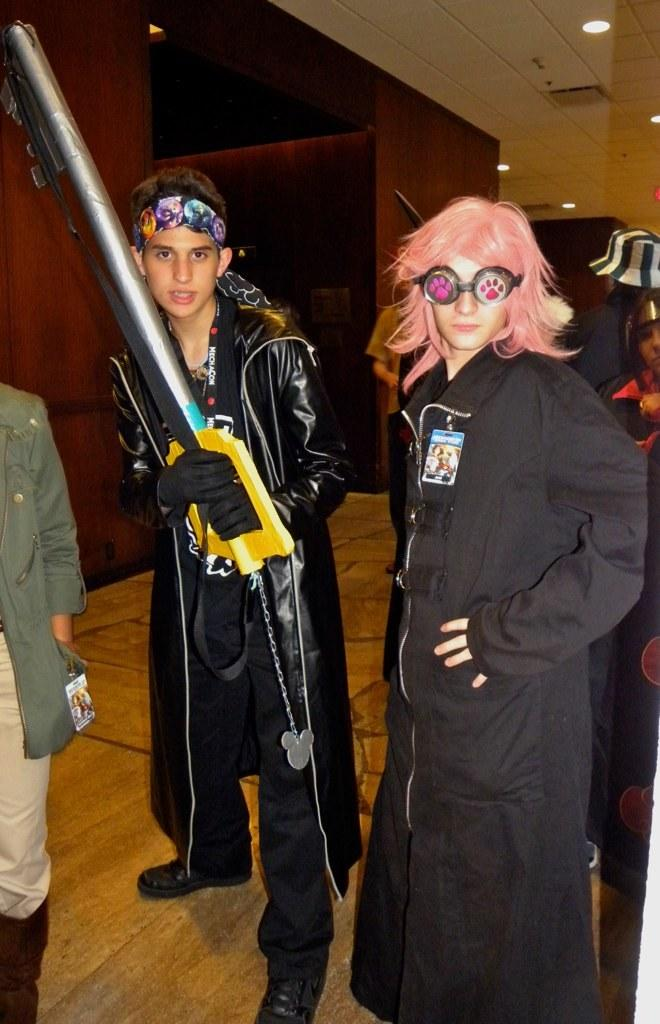What is happening in the image? There are people standing in the image. Can you describe what one of the people is doing? A person is holding an object in the image. What type of lighting is present in the image? There are lamps in the roof of the image. What is the taste of the sugar in the image? There is no sugar present in the image, so it is not possible to determine its taste. 